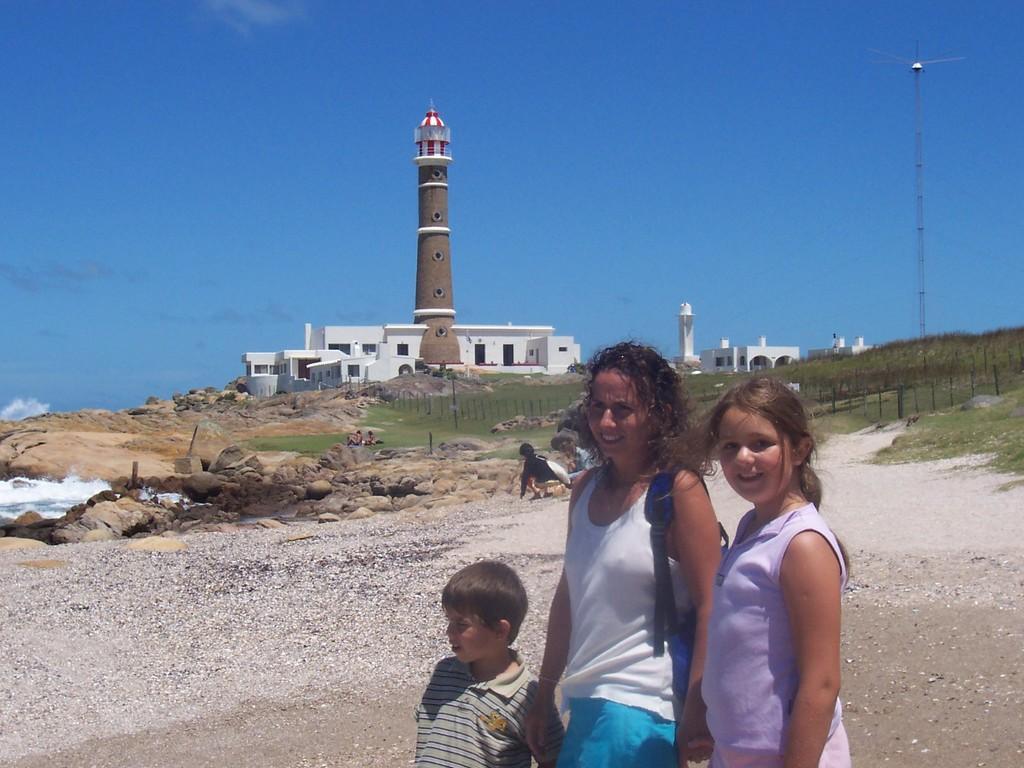In one or two sentences, can you explain what this image depicts? This picture is clicked outside and we can see the group of persons and we can see the gravels, rocks, water body, tower, buildings, metal rods and some other objects. In the background we can see the sky and the grass. 